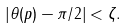<formula> <loc_0><loc_0><loc_500><loc_500>| \theta ( p ) - \pi / 2 | < \zeta .</formula> 